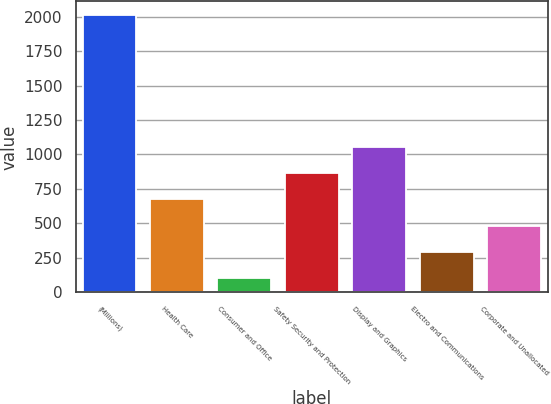Convert chart. <chart><loc_0><loc_0><loc_500><loc_500><bar_chart><fcel>(Millions)<fcel>Health Care<fcel>Consumer and Office<fcel>Safety Security and Protection<fcel>Display and Graphics<fcel>Electro and Communications<fcel>Corporate and Unallocated<nl><fcel>2010<fcel>673<fcel>100<fcel>864<fcel>1055<fcel>291<fcel>482<nl></chart> 